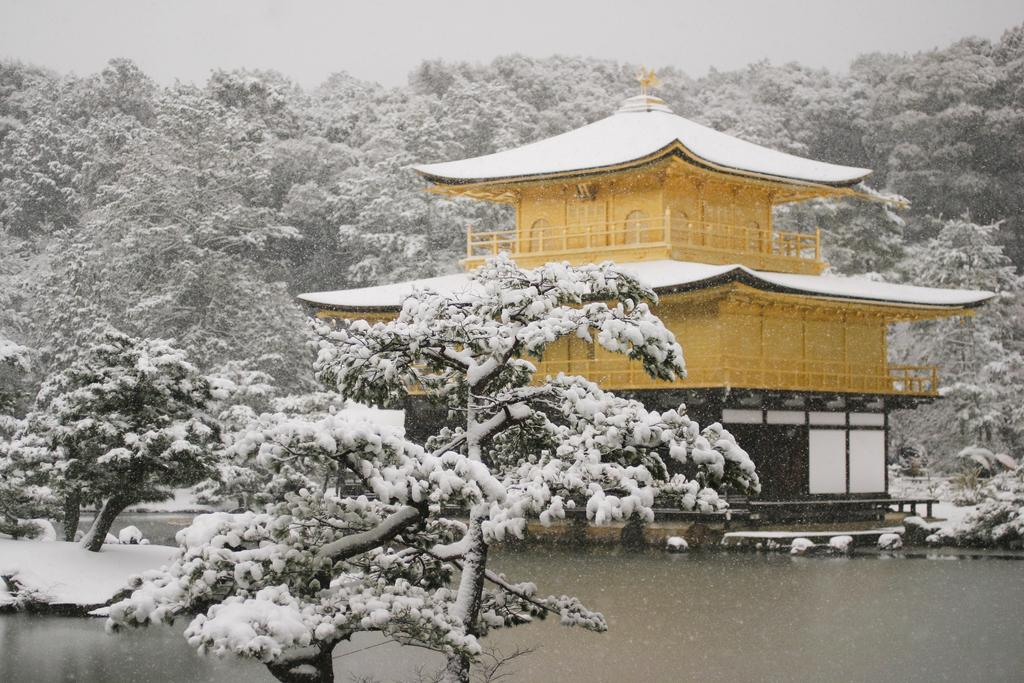What type of structure is visible in the image? There is a building in the image. What is the condition of the trees in the image? The trees in the image have snow on them. What can be seen at the bottom of the image? There is water visible at the bottom of the image. What is visible in the background of the image? The sky is visible in the background of the image. How many copies of the car can be seen in the image? There is no car present in the image. 